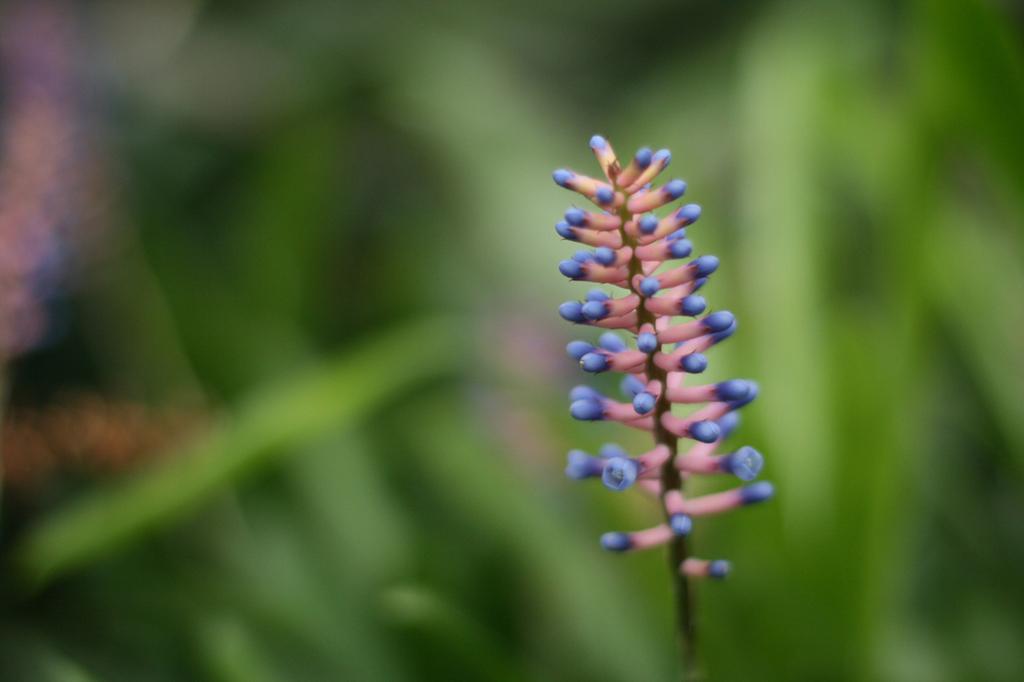Can you describe this image briefly? In this image in the front there is a plant and the background is blurry. 